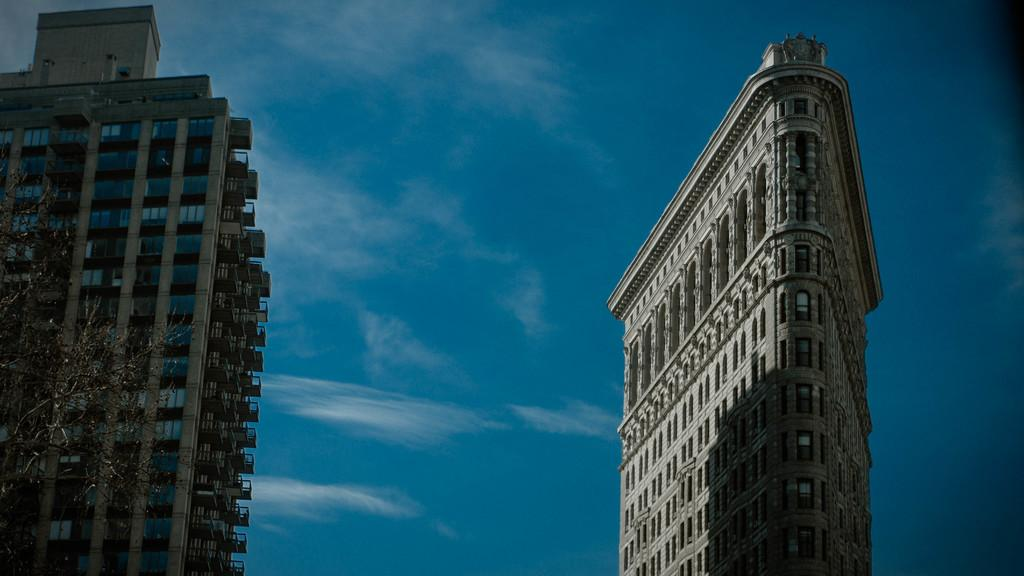What is the main subject in the center of the image? There are buildings in the center of the image. What can be seen in the background of the image? There is sky visible in the background of the image. What type of vegetation is on the left side of the image? There is a tree to the left side of the image. What type of fish can be seen swimming in the sky in the image? There are no fish present in the image, and the sky is not depicted as a body of water where fish could swim. 